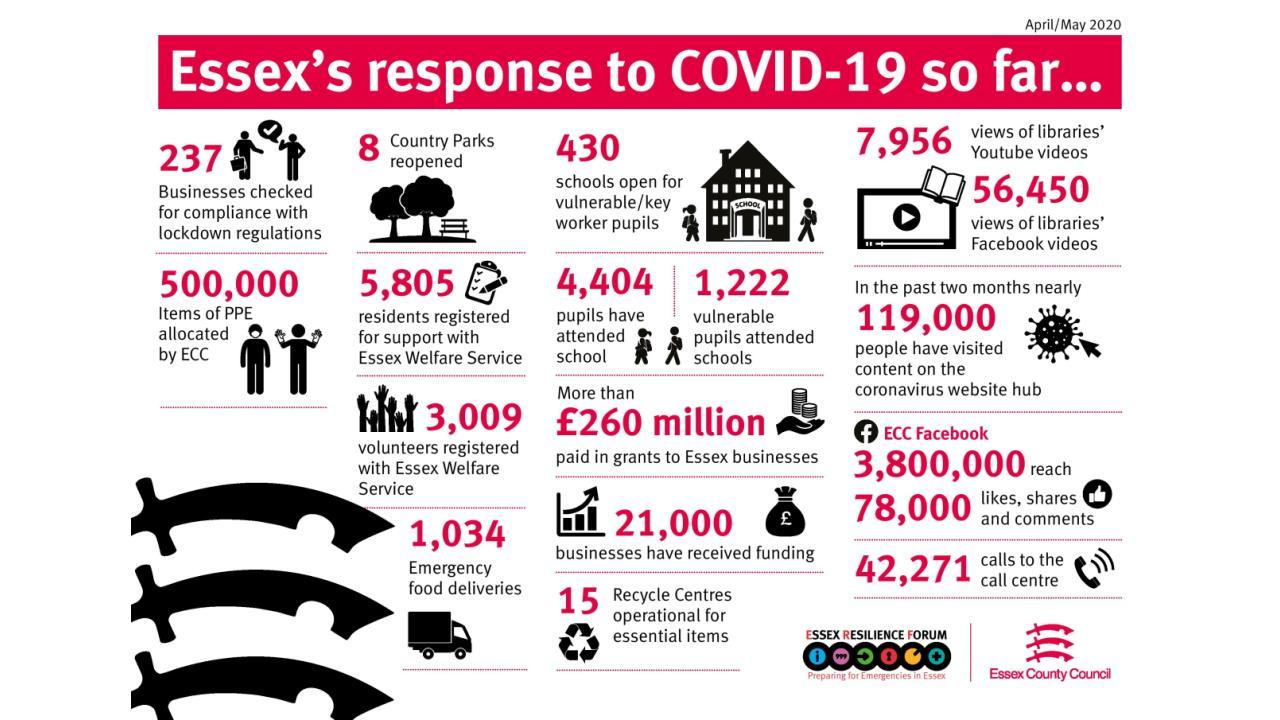How many medical gears were supplied by ECC?
Answer the question with a short phrase. 500,000 How many people asked for the help of Essex? 5,805 How many special children attended classes offline? 1,222 How many educational institutions of exceptional child's resumed working ? 430 How many companies started working for manufacturing the necessary goods? 15 How many recreational gardens were restarted? 8 How many enquiries were coming to the help desk of ECC? 42,271 How many packets of snacks were delivered during pandemic? 1,034 How many normal children went school during pandemic? 4,404 How many firms got help from ECC? 21,000 